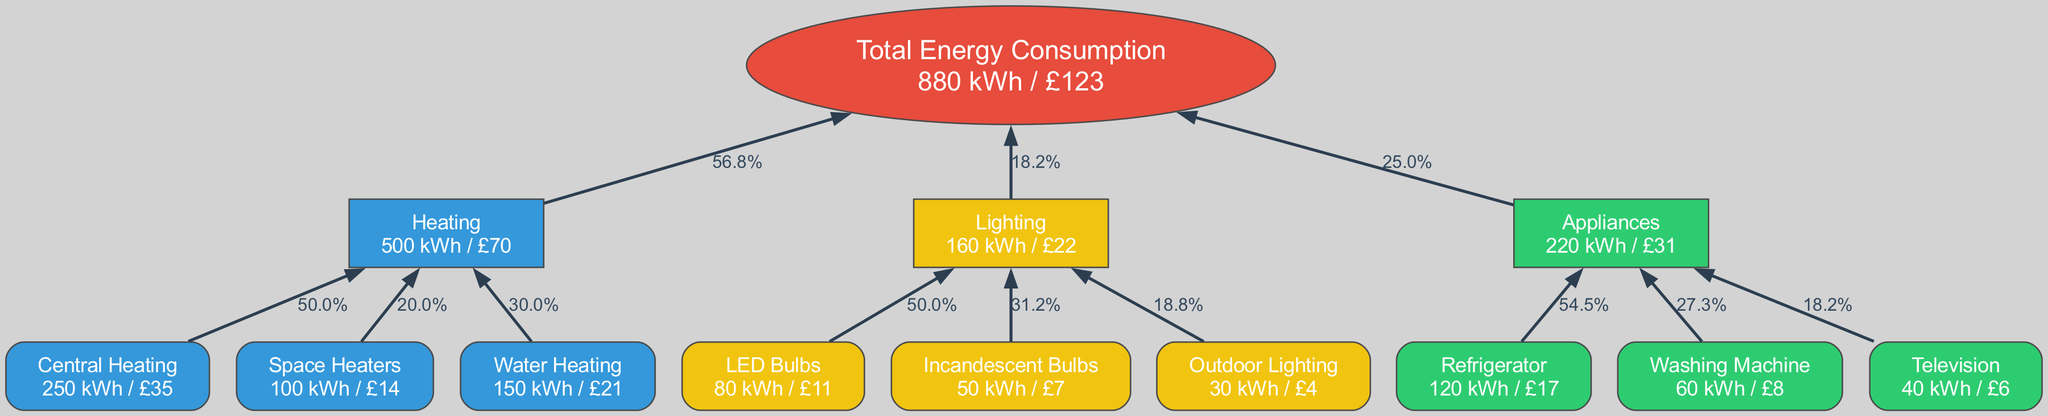what is the total energy consumption shown in the diagram? The total energy consumption is displayed in the "Total" node, which computes the sum of energy consumption from all categories. By adding up all the consumption values, we find the total is 750 kWh.
Answer: 750 kWh what is the cost associated with heating? To find the cost associated with heating, we look at the "Heating" category and sum the costs of its subcategories: Central Heating (£35), Space Heaters (£14), and Water Heating (£21). The total comes to £70.
Answer: £70 which category has the highest energy consumption? By examining the consumption values of each category, Heating (500 kWh) is found to have the highest energy consumption compared to Lighting (160 kWh) and Appliances (220 kWh).
Answer: Heating what percentage of total consumption is used for lighting? To find the percentage of total consumption used for lighting, we take the total lighting consumption (160 kWh) and divide it by the total consumption (750 kWh), then multiply by 100. This results in approximately 21.3%.
Answer: 21.3% which subcategory within appliances uses the least energy? We analyze the subcategories of Appliances: Refrigerator (120 kWh), Washing Machine (60 kWh), and Television (40 kWh). The Television has the least energy usage among them, at 40 kWh.
Answer: Television how much does water heating cost? The cost for water heating is displayed in its subcategory details under Heating, which states that it costs £21.
Answer: £21 what is the total cost of lighting in the home? To find the total cost of lighting, we add the costs of its subcategories: LED Bulbs (£11), Incandescent Bulbs (£7), and Outdoor Lighting (£4). This gives us a total of £22.
Answer: £22 which category accounts for the highest percentage of total cost? To determine the category accounting for the highest percentage of total cost, we compute the costs of each category: Heating (£70), Lighting (£22), and Appliances (£31). Heating has the highest cost, making up 64.1% of the total cost.
Answer: Heating which subcategory contributes most to heating costs? Reviewing the heating subcategories (Central Heating at £35, Space Heaters at £14, Water Heating at £21), we see that Central Heating contributes the most to the costs with £35.
Answer: Central Heating 